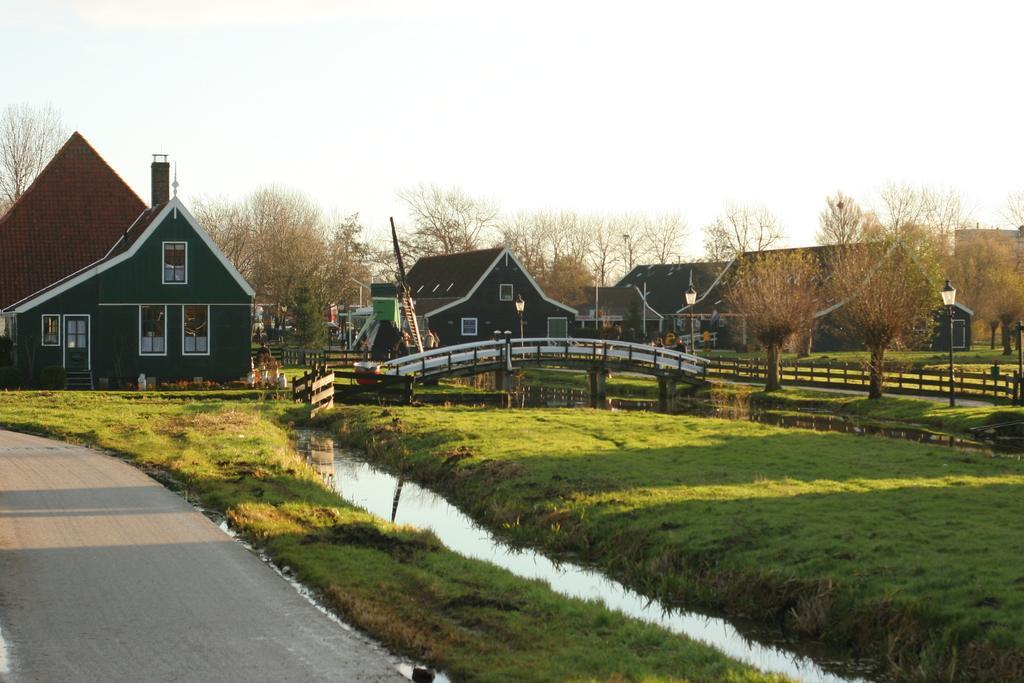Describe this image in one or two sentences. In this picture we can see grass and water in the front, there is a bridge in the middle, in the background there are some houses and trees, we can see the sky at the top of the picture. 